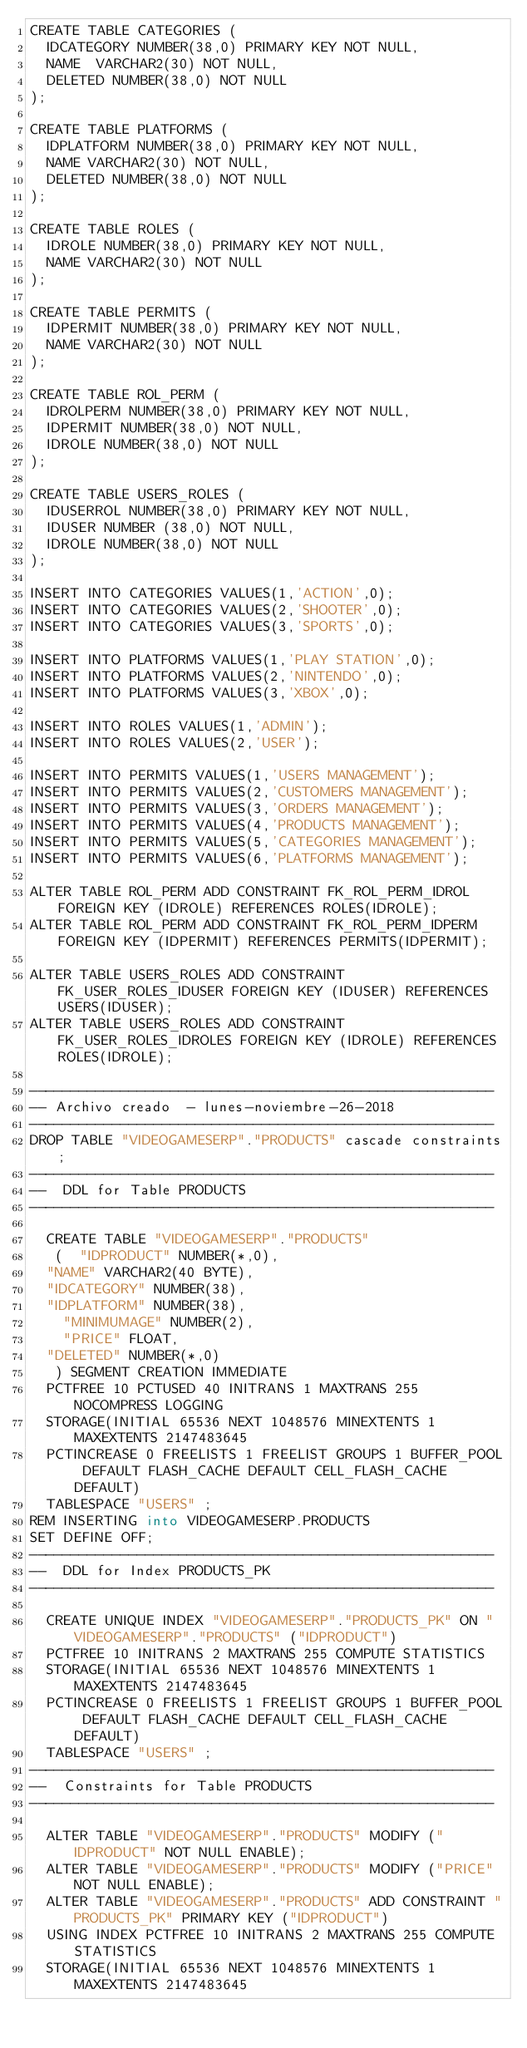Convert code to text. <code><loc_0><loc_0><loc_500><loc_500><_SQL_>CREATE TABLE CATEGORIES (
	IDCATEGORY NUMBER(38,0) PRIMARY KEY NOT NULL,
	NAME	VARCHAR2(30) NOT NULL,
	DELETED NUMBER(38,0) NOT NULL
);

CREATE TABLE PLATFORMS (
	IDPLATFORM NUMBER(38,0) PRIMARY KEY NOT NULL,
	NAME VARCHAR2(30) NOT NULL,
	DELETED NUMBER(38,0) NOT NULL
);

CREATE TABLE ROLES (
	IDROLE NUMBER(38,0) PRIMARY KEY NOT NULL,
	NAME VARCHAR2(30) NOT NULL
);

CREATE TABLE PERMITS (
	IDPERMIT NUMBER(38,0) PRIMARY KEY NOT NULL,
	NAME VARCHAR2(30)	NOT NULL
);

CREATE TABLE ROL_PERM (
	IDROLPERM NUMBER(38,0) PRIMARY KEY NOT NULL,
	IDPERMIT NUMBER(38,0) NOT NULL,
	IDROLE NUMBER(38,0) NOT NULL
);

CREATE TABLE USERS_ROLES (
	IDUSERROL NUMBER(38,0) PRIMARY KEY NOT NULL,
	IDUSER NUMBER (38,0) NOT NULL,
	IDROLE NUMBER(38,0) NOT NULL
);

INSERT INTO CATEGORIES VALUES(1,'ACTION',0);	
INSERT INTO CATEGORIES VALUES(2,'SHOOTER',0);
INSERT INTO CATEGORIES VALUES(3,'SPORTS',0);

INSERT INTO PLATFORMS VALUES(1,'PLAY STATION',0);
INSERT INTO PLATFORMS VALUES(2,'NINTENDO',0);
INSERT INTO PLATFORMS VALUES(3,'XBOX',0);

INSERT INTO ROLES VALUES(1,'ADMIN');
INSERT INTO ROLES VALUES(2,'USER');

INSERT INTO PERMITS VALUES(1,'USERS MANAGEMENT');
INSERT INTO PERMITS VALUES(2,'CUSTOMERS MANAGEMENT');
INSERT INTO PERMITS VALUES(3,'ORDERS MANAGEMENT');
INSERT INTO PERMITS VALUES(4,'PRODUCTS MANAGEMENT');
INSERT INTO PERMITS VALUES(5,'CATEGORIES MANAGEMENT');
INSERT INTO PERMITS VALUES(6,'PLATFORMS MANAGEMENT');

ALTER TABLE ROL_PERM ADD CONSTRAINT FK_ROL_PERM_IDROL FOREIGN KEY (IDROLE) REFERENCES ROLES(IDROLE);
ALTER TABLE ROL_PERM ADD CONSTRAINT FK_ROL_PERM_IDPERM FOREIGN KEY (IDPERMIT) REFERENCES PERMITS(IDPERMIT);

ALTER TABLE USERS_ROLES ADD CONSTRAINT FK_USER_ROLES_IDUSER FOREIGN KEY (IDUSER) REFERENCES USERS(IDUSER);
ALTER TABLE USERS_ROLES ADD CONSTRAINT FK_USER_ROLES_IDROLES FOREIGN KEY (IDROLE) REFERENCES ROLES(IDROLE);

--------------------------------------------------------
-- Archivo creado  - lunes-noviembre-26-2018   
--------------------------------------------------------
DROP TABLE "VIDEOGAMESERP"."PRODUCTS" cascade constraints;
--------------------------------------------------------
--  DDL for Table PRODUCTS
--------------------------------------------------------

  CREATE TABLE "VIDEOGAMESERP"."PRODUCTS" 
   (	"IDPRODUCT" NUMBER(*,0), 
	"NAME" VARCHAR2(40 BYTE), 
	"IDCATEGORY" NUMBER(38), 
	"IDPLATFORM" NUMBER(38),
    "MINIMUMAGE" NUMBER(2),
    "PRICE" FLOAT,
	"DELETED" NUMBER(*,0)
   ) SEGMENT CREATION IMMEDIATE 
  PCTFREE 10 PCTUSED 40 INITRANS 1 MAXTRANS 255 NOCOMPRESS LOGGING
  STORAGE(INITIAL 65536 NEXT 1048576 MINEXTENTS 1 MAXEXTENTS 2147483645
  PCTINCREASE 0 FREELISTS 1 FREELIST GROUPS 1 BUFFER_POOL DEFAULT FLASH_CACHE DEFAULT CELL_FLASH_CACHE DEFAULT)
  TABLESPACE "USERS" ;
REM INSERTING into VIDEOGAMESERP.PRODUCTS
SET DEFINE OFF;
--------------------------------------------------------
--  DDL for Index PRODUCTS_PK
--------------------------------------------------------

  CREATE UNIQUE INDEX "VIDEOGAMESERP"."PRODUCTS_PK" ON "VIDEOGAMESERP"."PRODUCTS" ("IDPRODUCT") 
  PCTFREE 10 INITRANS 2 MAXTRANS 255 COMPUTE STATISTICS 
  STORAGE(INITIAL 65536 NEXT 1048576 MINEXTENTS 1 MAXEXTENTS 2147483645
  PCTINCREASE 0 FREELISTS 1 FREELIST GROUPS 1 BUFFER_POOL DEFAULT FLASH_CACHE DEFAULT CELL_FLASH_CACHE DEFAULT)
  TABLESPACE "USERS" ;
--------------------------------------------------------
--  Constraints for Table PRODUCTS
--------------------------------------------------------

  ALTER TABLE "VIDEOGAMESERP"."PRODUCTS" MODIFY ("IDPRODUCT" NOT NULL ENABLE);
  ALTER TABLE "VIDEOGAMESERP"."PRODUCTS" MODIFY ("PRICE" NOT NULL ENABLE);
  ALTER TABLE "VIDEOGAMESERP"."PRODUCTS" ADD CONSTRAINT "PRODUCTS_PK" PRIMARY KEY ("IDPRODUCT")
  USING INDEX PCTFREE 10 INITRANS 2 MAXTRANS 255 COMPUTE STATISTICS 
  STORAGE(INITIAL 65536 NEXT 1048576 MINEXTENTS 1 MAXEXTENTS 2147483645</code> 